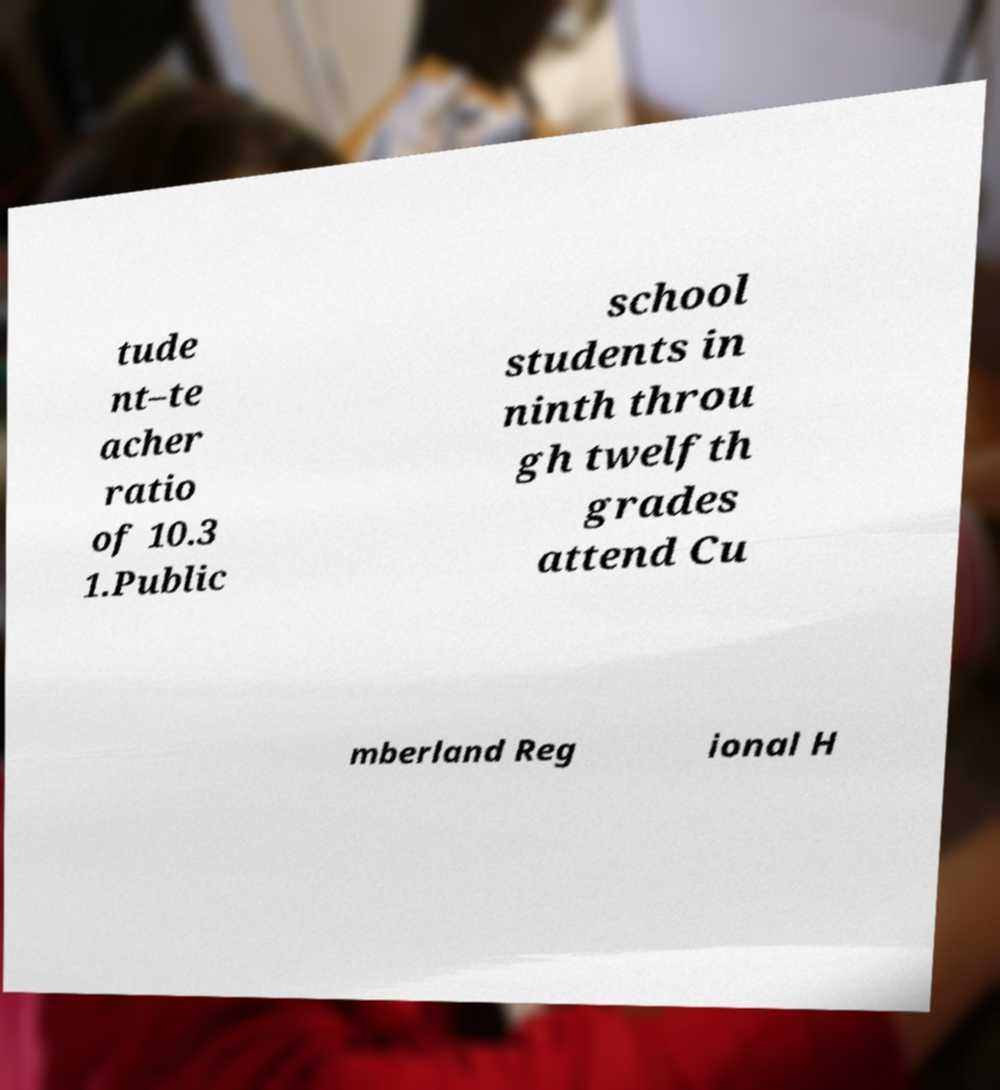There's text embedded in this image that I need extracted. Can you transcribe it verbatim? tude nt–te acher ratio of 10.3 1.Public school students in ninth throu gh twelfth grades attend Cu mberland Reg ional H 